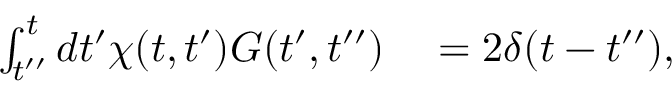Convert formula to latex. <formula><loc_0><loc_0><loc_500><loc_500>\begin{array} { r l } { \int _ { t ^ { \prime \prime } } ^ { t } d t ^ { \prime } \chi ( t , t ^ { \prime } ) G ( t ^ { \prime } , t ^ { \prime \prime } ) } & = 2 \delta ( t - t ^ { \prime \prime } ) , } \end{array}</formula> 